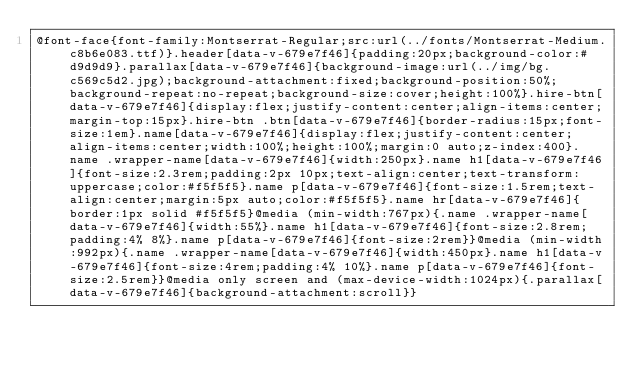Convert code to text. <code><loc_0><loc_0><loc_500><loc_500><_CSS_>@font-face{font-family:Montserrat-Regular;src:url(../fonts/Montserrat-Medium.c8b6e083.ttf)}.header[data-v-679e7f46]{padding:20px;background-color:#d9d9d9}.parallax[data-v-679e7f46]{background-image:url(../img/bg.c569c5d2.jpg);background-attachment:fixed;background-position:50%;background-repeat:no-repeat;background-size:cover;height:100%}.hire-btn[data-v-679e7f46]{display:flex;justify-content:center;align-items:center;margin-top:15px}.hire-btn .btn[data-v-679e7f46]{border-radius:15px;font-size:1em}.name[data-v-679e7f46]{display:flex;justify-content:center;align-items:center;width:100%;height:100%;margin:0 auto;z-index:400}.name .wrapper-name[data-v-679e7f46]{width:250px}.name h1[data-v-679e7f46]{font-size:2.3rem;padding:2px 10px;text-align:center;text-transform:uppercase;color:#f5f5f5}.name p[data-v-679e7f46]{font-size:1.5rem;text-align:center;margin:5px auto;color:#f5f5f5}.name hr[data-v-679e7f46]{border:1px solid #f5f5f5}@media (min-width:767px){.name .wrapper-name[data-v-679e7f46]{width:55%}.name h1[data-v-679e7f46]{font-size:2.8rem;padding:4% 8%}.name p[data-v-679e7f46]{font-size:2rem}}@media (min-width:992px){.name .wrapper-name[data-v-679e7f46]{width:450px}.name h1[data-v-679e7f46]{font-size:4rem;padding:4% 10%}.name p[data-v-679e7f46]{font-size:2.5rem}}@media only screen and (max-device-width:1024px){.parallax[data-v-679e7f46]{background-attachment:scroll}}</code> 